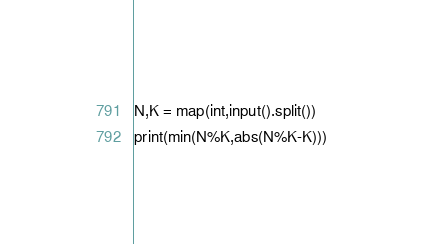<code> <loc_0><loc_0><loc_500><loc_500><_Python_>N,K = map(int,input().split())
print(min(N%K,abs(N%K-K)))</code> 